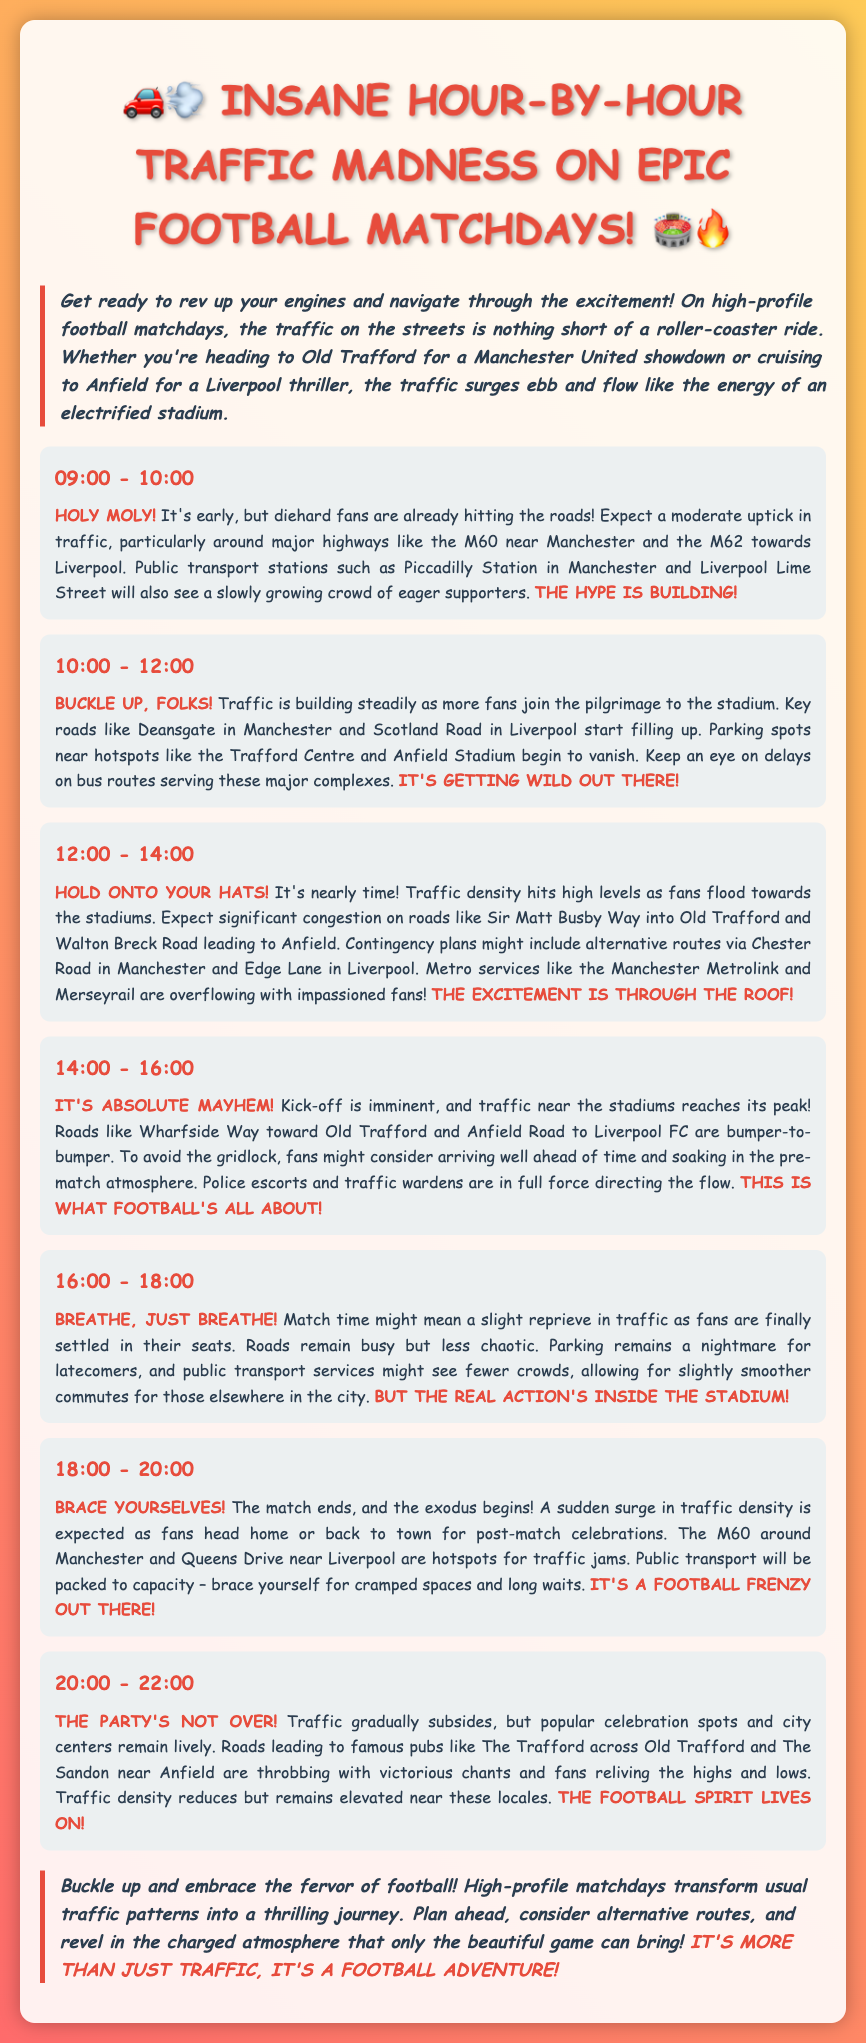What time does traffic density start to build steadily? The segment for 10:00 - 12:00 indicates that traffic is building steadily during this time.
Answer: 10:00 - 12:00 What roads see significant congestion just before kick-off? The description for 12:00 - 14:00 mentions significant congestion on Sir Matt Busby Way and Walton Breck Road.
Answer: Sir Matt Busby Way, Walton Breck Road What is expected right before the match starts? The segment for 14:00 - 16:00 indicates that it's absolute mayhem as traffic peaks near the stadiums.
Answer: Absolute mayhem When do fans start heading home after the match? The segment for 18:00 - 20:00 discusses the exodus of fans heading home.
Answer: 18:00 - 20:00 What might happen to public transport services during peak traffic times? Throughout the report, especially in segments leading up to the matches, public transport is mentioned as being packed to capacity.
Answer: Packed to capacity What is the main traffic condition noted from 16:00 to 18:00? The report states that traffic remains busy but less chaotic once fans are in their seats.
Answer: Busy but less chaotic What is a suggested alternative route during high traffic heading to the stadium? The segment for 12:00 - 14:00 suggests alternative routes via Chester Road in Manchester and Edge Lane in Liverpool.
Answer: Chester Road, Edge Lane What characterizes the traffic from 20:00 to 22:00? The segment describes that traffic gradually subsides but remains elevated near celebration spots.
Answer: Gradually subsides but remains elevated 